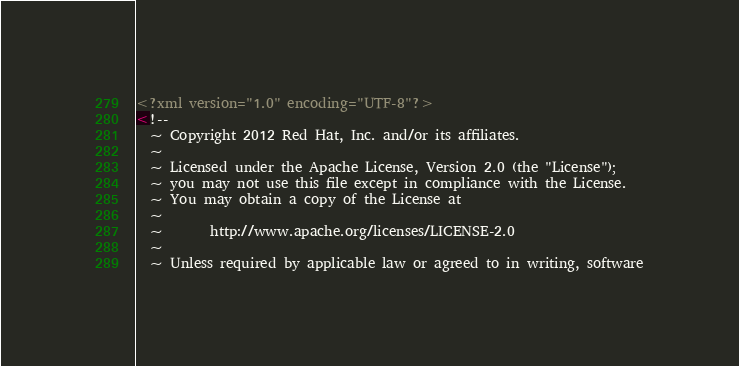<code> <loc_0><loc_0><loc_500><loc_500><_XML_><?xml version="1.0" encoding="UTF-8"?>
<!--
  ~ Copyright 2012 Red Hat, Inc. and/or its affiliates.
  ~
  ~ Licensed under the Apache License, Version 2.0 (the "License");
  ~ you may not use this file except in compliance with the License.
  ~ You may obtain a copy of the License at
  ~
  ~       http://www.apache.org/licenses/LICENSE-2.0
  ~
  ~ Unless required by applicable law or agreed to in writing, software</code> 